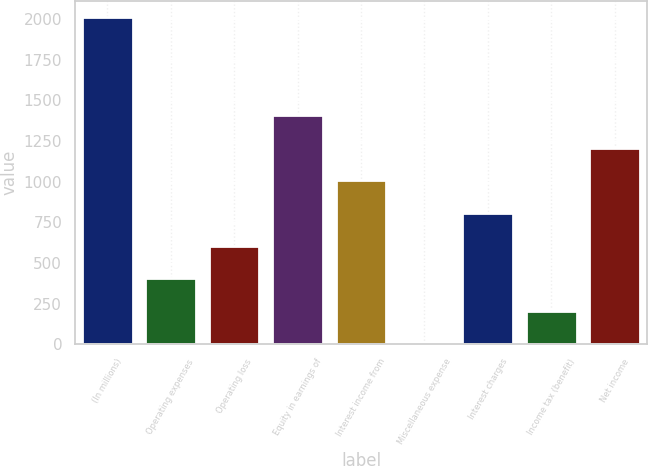<chart> <loc_0><loc_0><loc_500><loc_500><bar_chart><fcel>(In millions)<fcel>Operating expenses<fcel>Operating loss<fcel>Equity in earnings of<fcel>Interest income from<fcel>Miscellaneous expense<fcel>Interest charges<fcel>Income tax (benefit)<fcel>Net income<nl><fcel>2011<fcel>405.4<fcel>606.1<fcel>1408.9<fcel>1007.5<fcel>4<fcel>806.8<fcel>204.7<fcel>1208.2<nl></chart> 